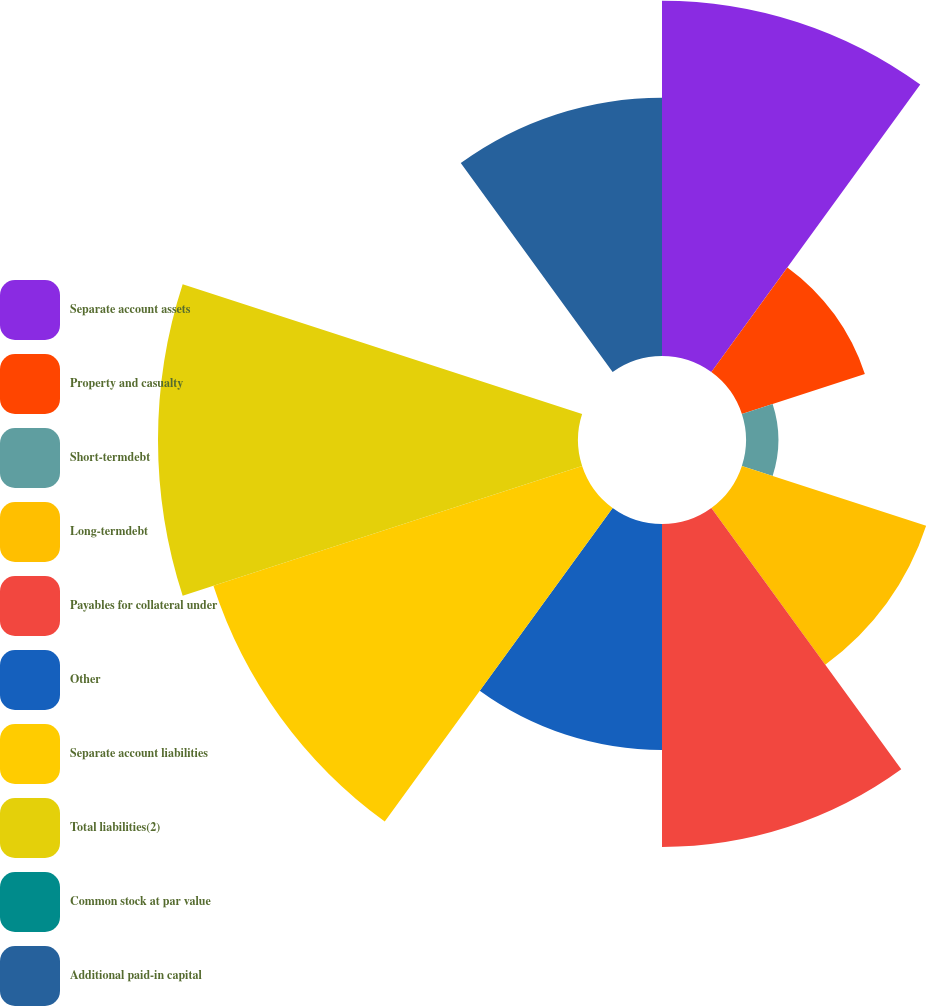Convert chart. <chart><loc_0><loc_0><loc_500><loc_500><pie_chart><fcel>Separate account assets<fcel>Property and casualty<fcel>Short-termdebt<fcel>Long-termdebt<fcel>Payables for collateral under<fcel>Other<fcel>Separate account liabilities<fcel>Total liabilities(2)<fcel>Common stock at par value<fcel>Additional paid-in capital<nl><fcel>15.28%<fcel>5.56%<fcel>1.39%<fcel>8.33%<fcel>13.89%<fcel>9.72%<fcel>16.67%<fcel>18.06%<fcel>0.0%<fcel>11.11%<nl></chart> 